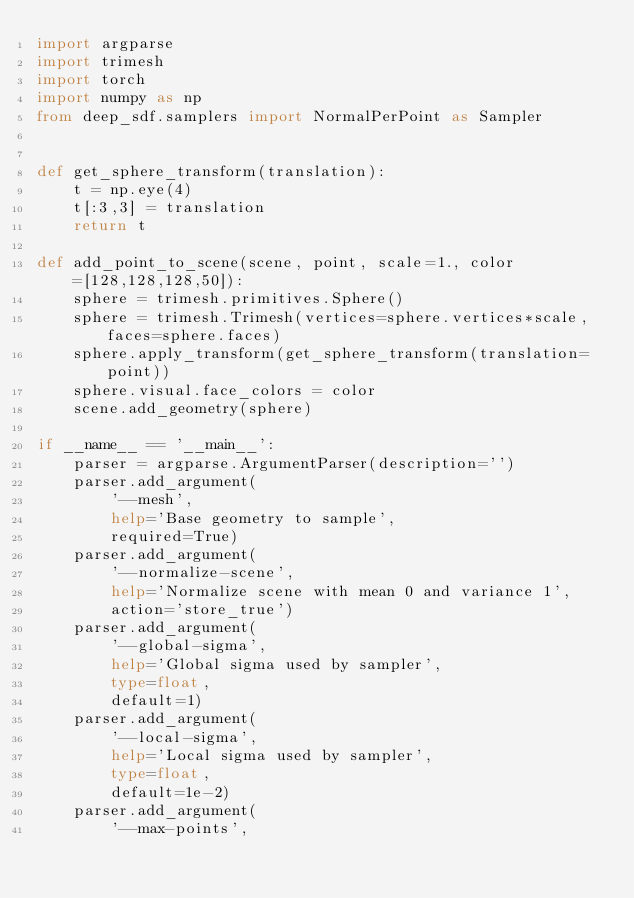<code> <loc_0><loc_0><loc_500><loc_500><_Python_>import argparse
import trimesh
import torch
import numpy as np
from deep_sdf.samplers import NormalPerPoint as Sampler


def get_sphere_transform(translation):
    t = np.eye(4)
    t[:3,3] = translation
    return t

def add_point_to_scene(scene, point, scale=1., color=[128,128,128,50]):
    sphere = trimesh.primitives.Sphere()
    sphere = trimesh.Trimesh(vertices=sphere.vertices*scale, faces=sphere.faces)
    sphere.apply_transform(get_sphere_transform(translation=point))
    sphere.visual.face_colors = color
    scene.add_geometry(sphere)

if __name__ == '__main__':
    parser = argparse.ArgumentParser(description='')
    parser.add_argument(
        '--mesh',
        help='Base geometry to sample',
        required=True)
    parser.add_argument(
        '--normalize-scene',
        help='Normalize scene with mean 0 and variance 1',
        action='store_true')
    parser.add_argument(
        '--global-sigma',
        help='Global sigma used by sampler',
        type=float,
        default=1)
    parser.add_argument(
        '--local-sigma',
        help='Local sigma used by sampler',
        type=float,
        default=1e-2)
    parser.add_argument(
        '--max-points',</code> 